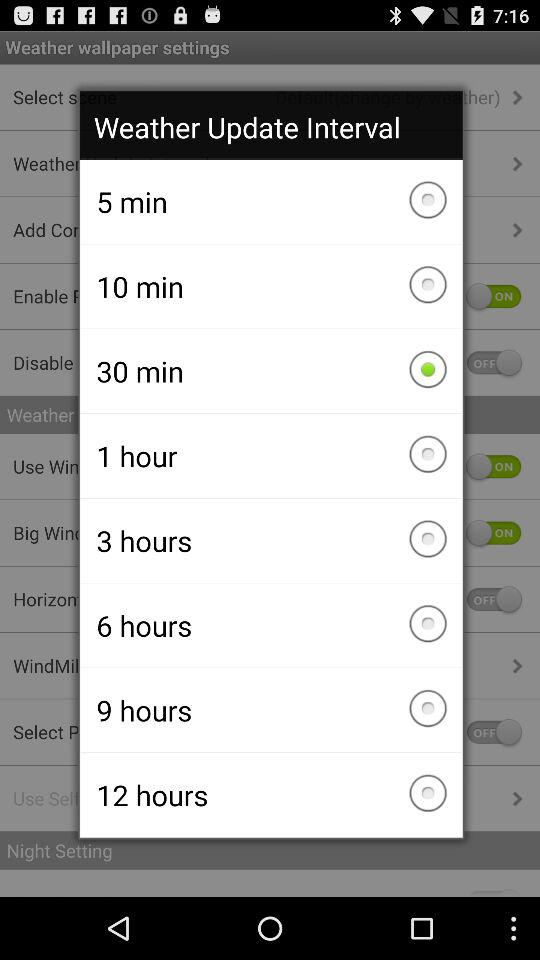What is the weather?
When the provided information is insufficient, respond with <no answer>. <no answer> 